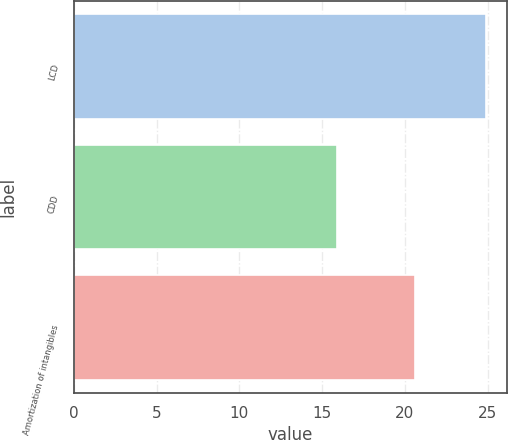Convert chart to OTSL. <chart><loc_0><loc_0><loc_500><loc_500><bar_chart><fcel>LCD<fcel>CDD<fcel>Amortization of intangibles<nl><fcel>24.9<fcel>15.9<fcel>20.6<nl></chart> 